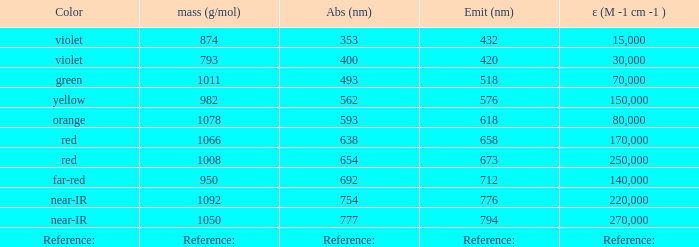Which Emission (in nanometers) has an absorbtion of 593 nm? 618.0. 